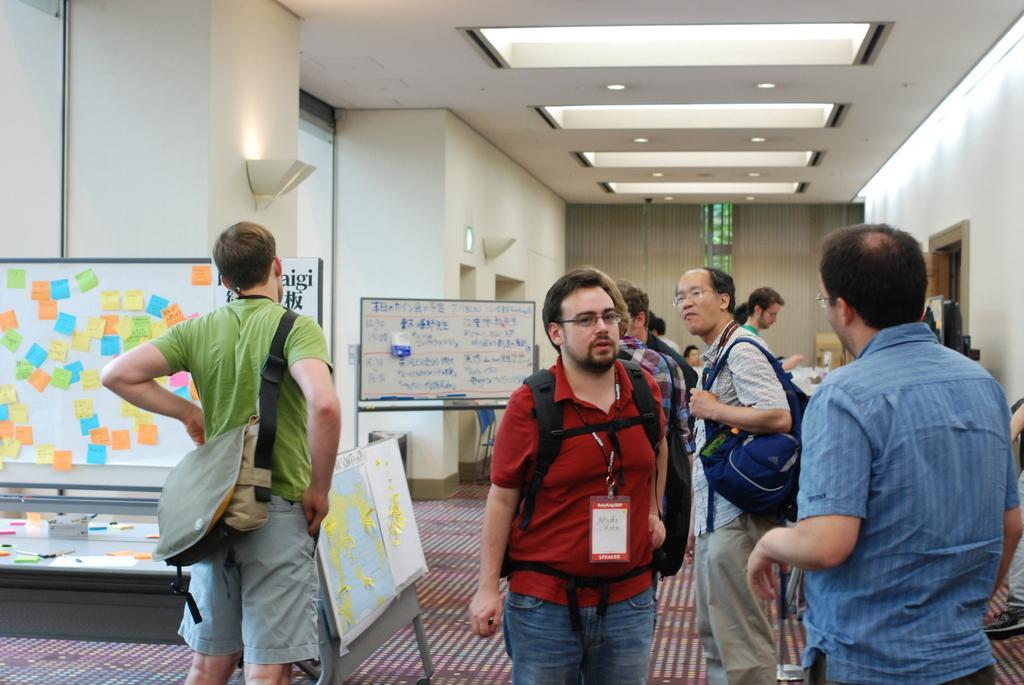Describe this image in one or two sentences. In this image there are persons, there are persons wearing bags, there are blinds, there are objects on the surface, there is a wall truncated towards the right of the image, there is a person truncated towards the right of the image, there is a roof, there are lights on the roof, there are boards, there is text on the boards, there is a board truncated towards the left of the image, there are windows, there is a window truncated towards the left of the image, there are lights on the wall. 